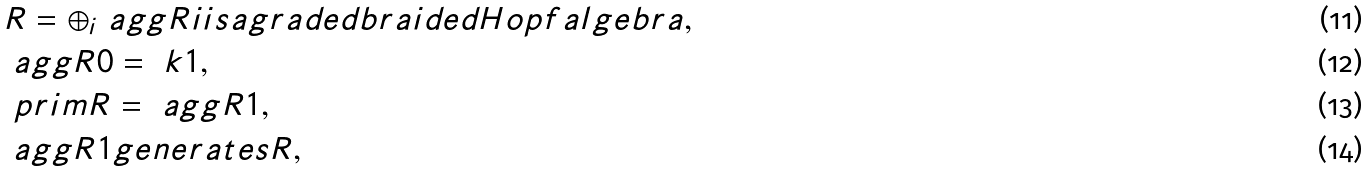<formula> <loc_0><loc_0><loc_500><loc_500>& R = \oplus _ { i } \ a g g R i i s a g r a d e d b r a i d e d H o p f a l g e b r a , \\ & \ a g g R 0 = \ k 1 , \\ & \ p r i m R = \ a g g R 1 , \\ & \ a g g R 1 g e n e r a t e s R ,</formula> 